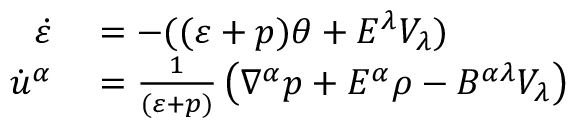Convert formula to latex. <formula><loc_0><loc_0><loc_500><loc_500>\begin{array} { r l } { \dot { \varepsilon } } & = - ( ( \varepsilon + p ) \theta + E ^ { \lambda } V _ { \lambda } ) } \\ { \dot { u } ^ { \alpha } } & = \frac { 1 } { ( \varepsilon + p ) } \left ( \nabla ^ { \alpha } p + E ^ { \alpha } \rho - B ^ { \alpha \lambda } V _ { \lambda } \right ) } \end{array}</formula> 